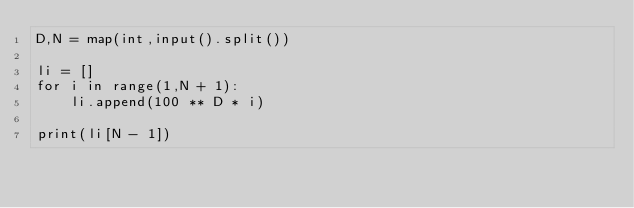Convert code to text. <code><loc_0><loc_0><loc_500><loc_500><_Python_>D,N = map(int,input().split())

li = []
for i in range(1,N + 1):
    li.append(100 ** D * i)

print(li[N - 1])</code> 